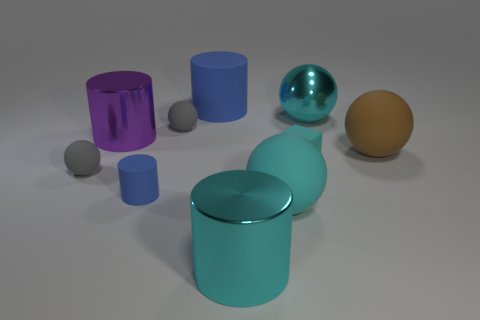How many big blue things are the same shape as the large purple thing?
Provide a short and direct response. 1. What is the shape of the blue matte object that is the same size as the cyan rubber sphere?
Your response must be concise. Cylinder. There is a large cyan rubber object; are there any large matte things behind it?
Provide a succinct answer. Yes. There is a blue cylinder in front of the brown rubber ball; are there any matte objects to the left of it?
Ensure brevity in your answer.  Yes. Is the number of large cyan metal objects that are in front of the large cyan metal ball less than the number of small objects in front of the tiny rubber block?
Ensure brevity in your answer.  Yes. What is the shape of the large blue rubber object?
Make the answer very short. Cylinder. What is the large sphere behind the large purple object made of?
Provide a succinct answer. Metal. There is a blue object that is behind the cyan sphere that is behind the gray matte ball behind the brown ball; what is its size?
Your response must be concise. Large. Is the material of the large cylinder to the left of the big rubber cylinder the same as the cyan cube that is behind the tiny cylinder?
Keep it short and to the point. No. What number of other things are there of the same color as the tiny cylinder?
Provide a succinct answer. 1. 